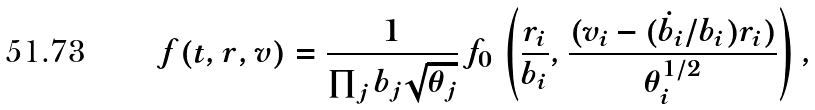<formula> <loc_0><loc_0><loc_500><loc_500>f ( t , r , v ) = \frac { 1 } { \prod _ { j } b _ { j } \sqrt { \theta _ { j } } } \, f _ { 0 } \, \left ( \frac { r _ { i } } { b _ { i } } , \frac { ( v _ { i } - ( \dot { b } _ { i } / b _ { i } ) r _ { i } ) } { \theta _ { i } ^ { 1 / 2 } } \right ) ,</formula> 